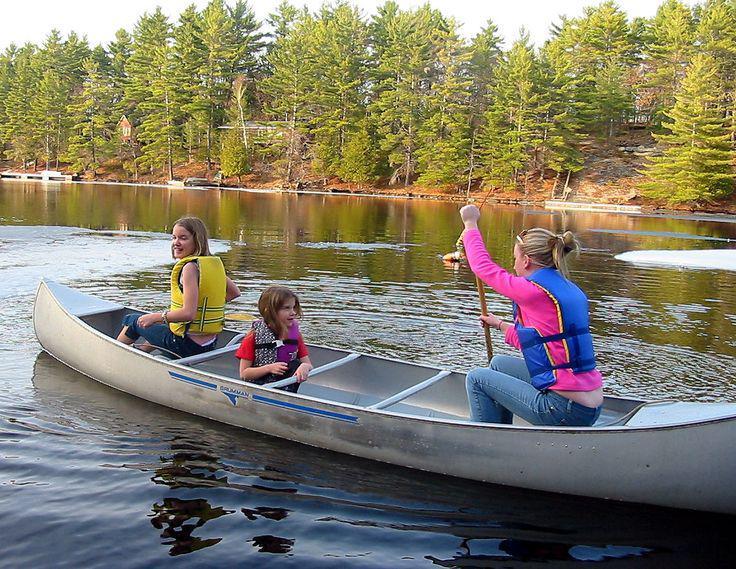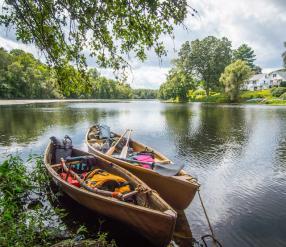The first image is the image on the left, the second image is the image on the right. Evaluate the accuracy of this statement regarding the images: "One of the images contains exactly two canoes.". Is it true? Answer yes or no. Yes. The first image is the image on the left, the second image is the image on the right. Analyze the images presented: Is the assertion "There are exactly two boats in the image on the right." valid? Answer yes or no. Yes. 